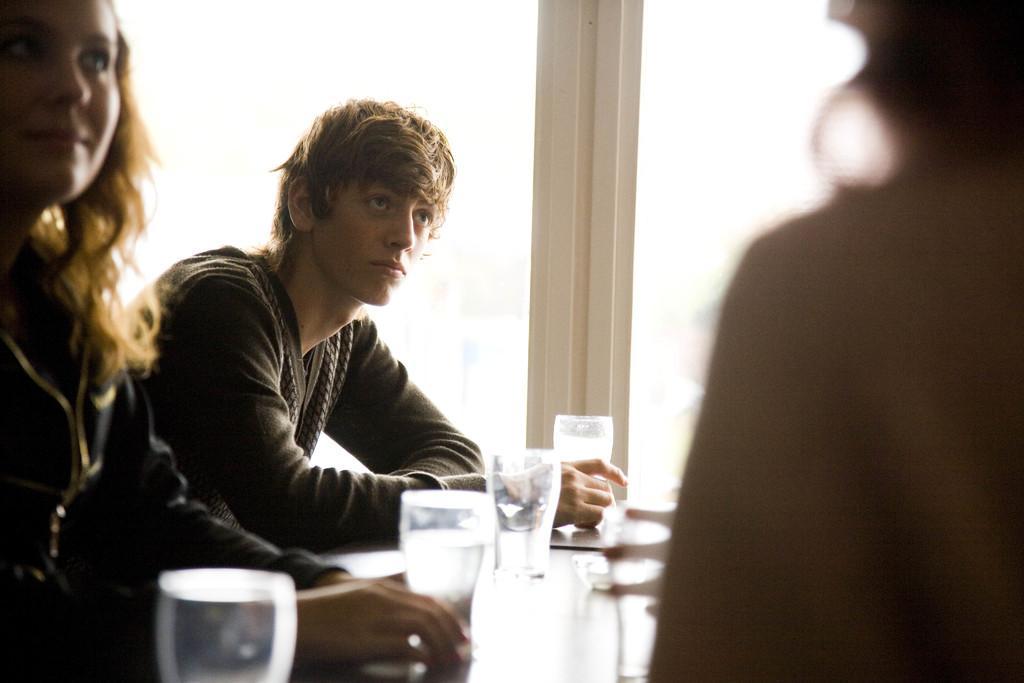How would you summarize this image in a sentence or two? There are two persons sitting in chair and there is a table in front of them which has a glass of water on it and there is another person in the right corner. 